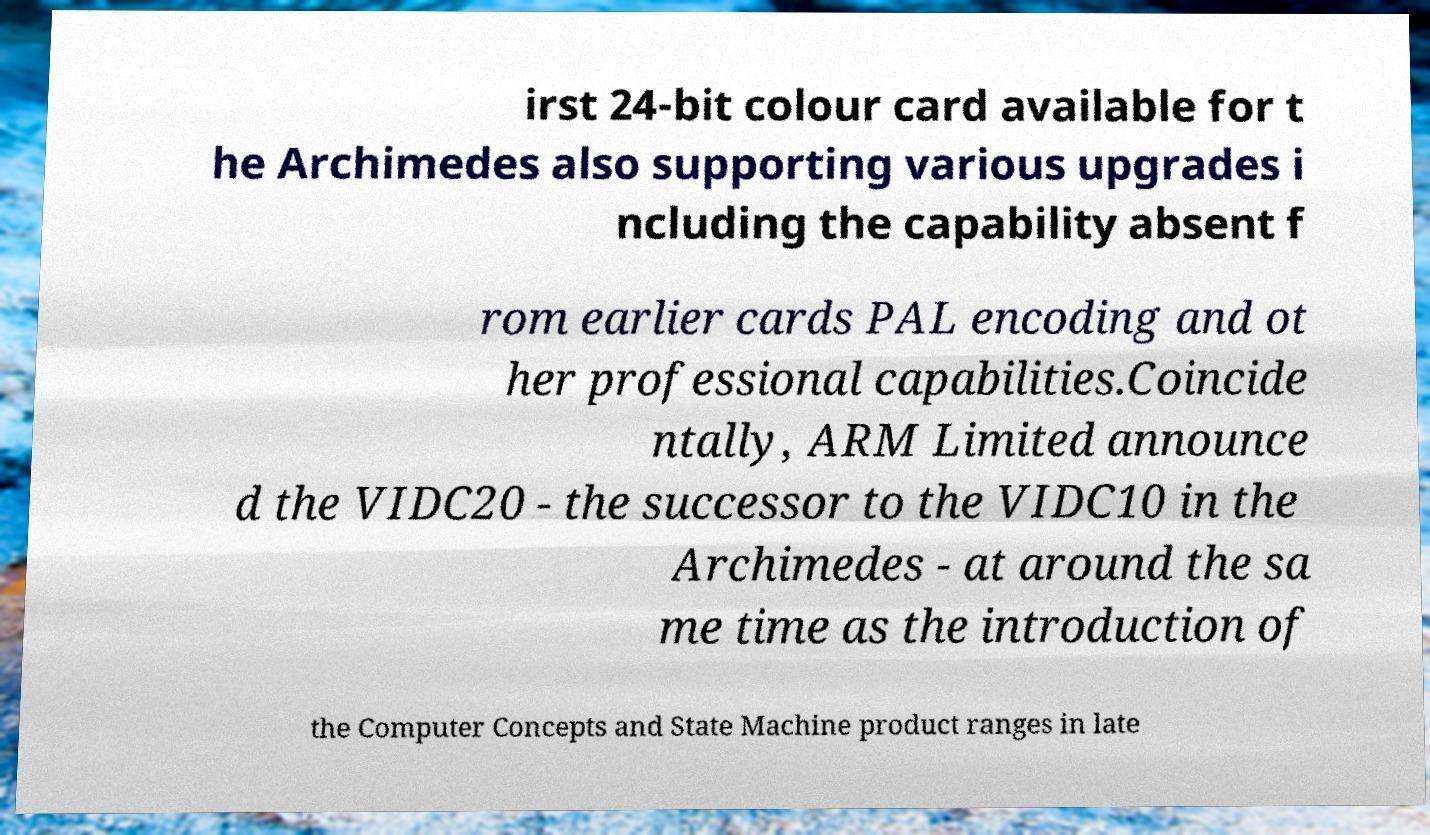Could you assist in decoding the text presented in this image and type it out clearly? irst 24-bit colour card available for t he Archimedes also supporting various upgrades i ncluding the capability absent f rom earlier cards PAL encoding and ot her professional capabilities.Coincide ntally, ARM Limited announce d the VIDC20 - the successor to the VIDC10 in the Archimedes - at around the sa me time as the introduction of the Computer Concepts and State Machine product ranges in late 